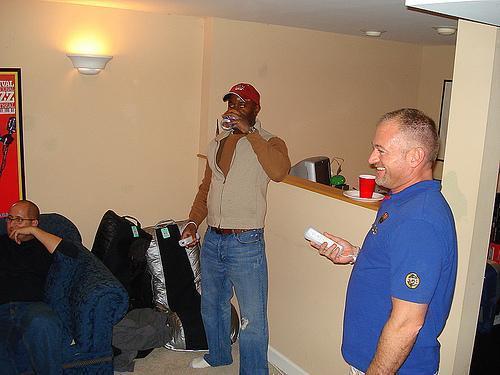What happen to the eyes of the man who is drinking?
Select the accurate response from the four choices given to answer the question.
Options: Wearing makeup, blindness, light reflection, closed eyes. Light reflection. 